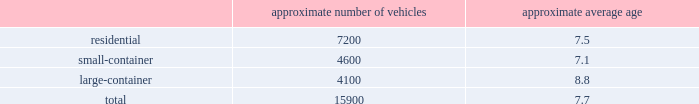Acquire operations and facilities from municipalities and other local governments , as they increasingly seek to raise capital and reduce risk .
We realize synergies from consolidating businesses into our existing operations , whether through acquisitions or public-private partnerships , which allows us to reduce capital expenditures and expenses associated with truck routing , personnel , fleet maintenance , inventories and back-office administration .
Operating model the goal of our operating model pillar is to deliver a consistent , high-quality service to all of our customers through the republic way : one way .
Everywhere .
Every day .
This approach of developing standardized processes with rigorous controls and tracking allows us to leverage our scale and deliver durable operational excellence .
The republic way is the key to harnessing the best of what we do as operators and translating that across all facets of our business .
A key enabler of the republic way is our organizational structure that fosters a high performance culture by maintaining 360-degree accountability and full profit and loss responsibility with local management , supported by a functional structure to provide subject matter expertise .
This structure allows us to take advantage of our scale by coordinating functionally across all of our markets , while empowering local management to respond to unique market dynamics .
We have rolled out several productivity and cost control initiatives designed to deliver the best service possible to our customers in the most efficient and environmentally sound way .
Fleet automation approximately 75% ( 75 % ) of our residential routes have been converted to automated single-driver trucks .
By converting our residential routes to automated service , we reduce labor costs , improve driver productivity , decrease emissions and create a safer work environment for our employees .
Additionally , communities using automated vehicles have higher participation rates in recycling programs , thereby complementing our initiative to expand our recycling capabilities .
Fleet conversion to compressed natural gas ( cng ) approximately 19% ( 19 % ) of our fleet operates on natural gas .
We expect to continue our gradual fleet conversion to cng as part of our ordinary annual fleet replacement process .
We believe a gradual fleet conversion is the most prudent approach to realizing the full value of our previous fleet investments .
Approximately 30% ( 30 % ) of our replacement vehicle purchases during 2017 were cng vehicles .
We believe using cng vehicles provides us a competitive advantage in communities with strict clean emission initiatives that focus on protecting the environment .
Although upfront capital costs are higher , using cng reduces our overall fleet operating costs through lower fuel expenses .
As of december 31 , 2017 , we operated 37 cng fueling stations .
Standardized maintenance based on an industry trade publication , we operate the seventh largest vocational fleet in the united states .
As of december 31 , 2017 , our average fleet age in years , by line of business , was as follows : approximate number of vehicles approximate average age .

What is the ratio of the number of vehicles for residential compared to large-container? 
Rationale: the ratio of residential vehicles to large-container is 1.73 to 1
Computations: (7200 / 4100)
Answer: 1.7561. 